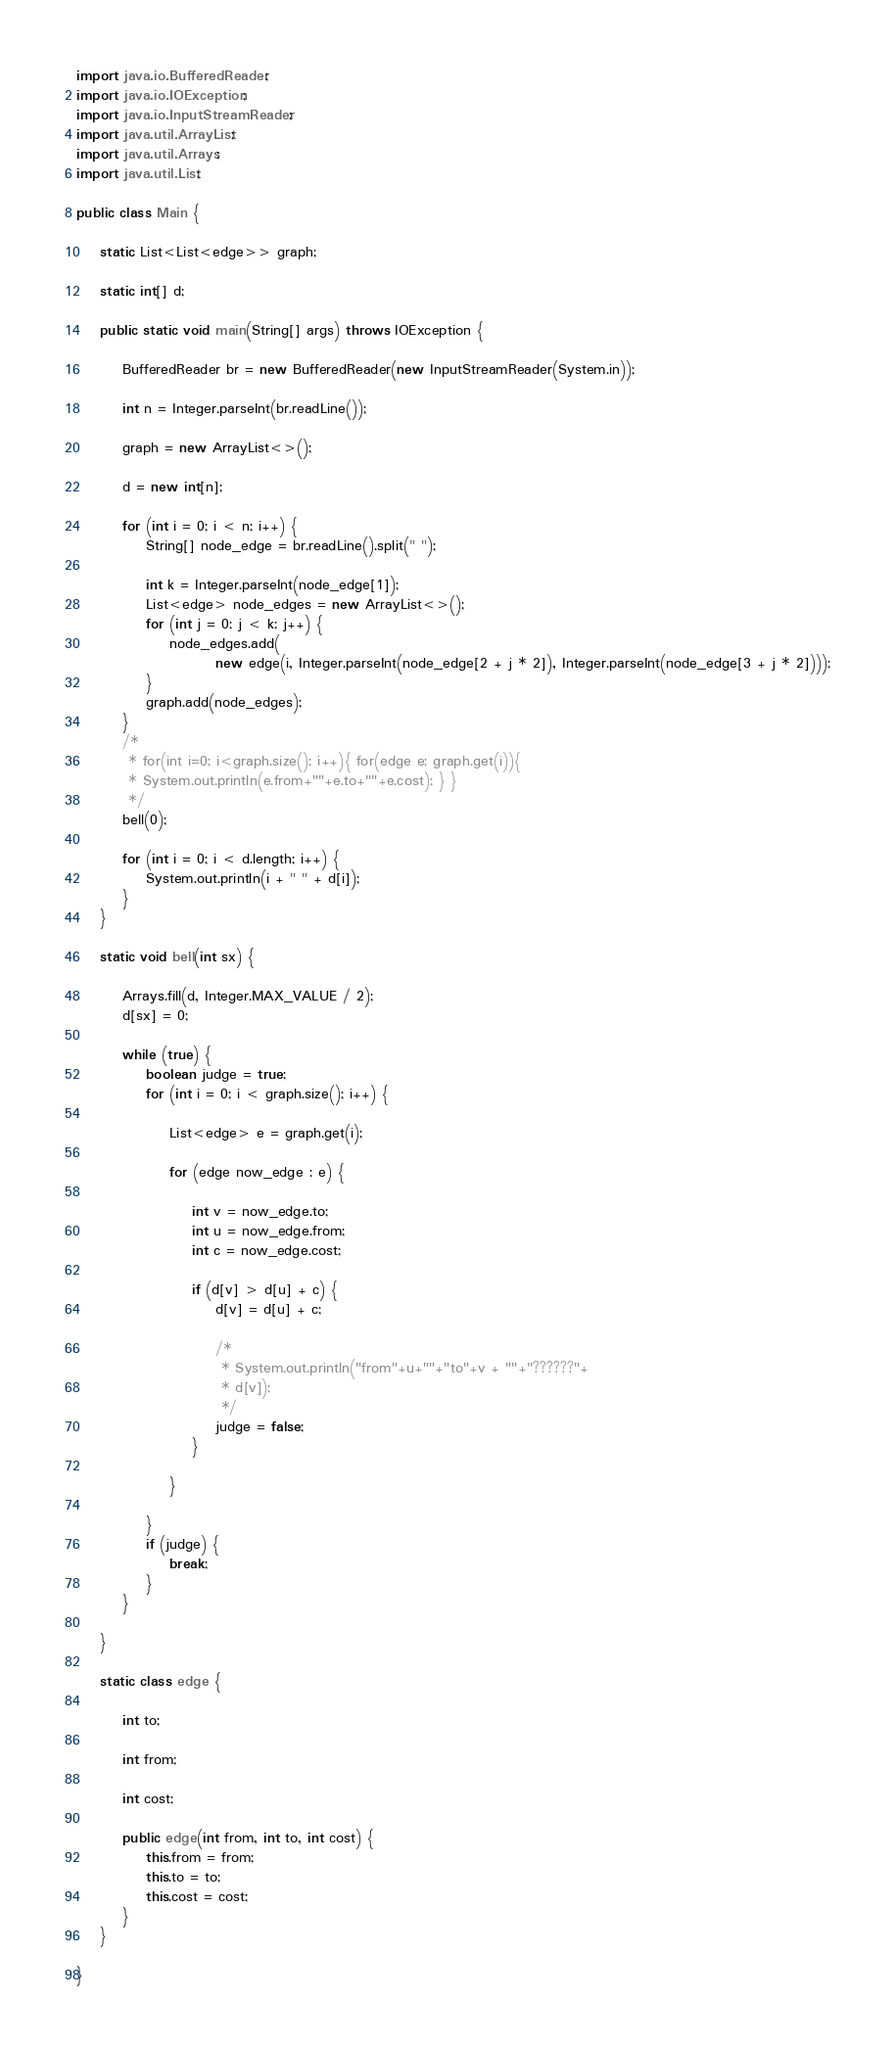Convert code to text. <code><loc_0><loc_0><loc_500><loc_500><_Java_>import java.io.BufferedReader;
import java.io.IOException;
import java.io.InputStreamReader;
import java.util.ArrayList;
import java.util.Arrays;
import java.util.List;

public class Main {

	static List<List<edge>> graph;

	static int[] d;

	public static void main(String[] args) throws IOException {

		BufferedReader br = new BufferedReader(new InputStreamReader(System.in));

		int n = Integer.parseInt(br.readLine());

		graph = new ArrayList<>();

		d = new int[n];

		for (int i = 0; i < n; i++) {
			String[] node_edge = br.readLine().split(" ");

			int k = Integer.parseInt(node_edge[1]);
			List<edge> node_edges = new ArrayList<>();
			for (int j = 0; j < k; j++) {
				node_edges.add(
						new edge(i, Integer.parseInt(node_edge[2 + j * 2]), Integer.parseInt(node_edge[3 + j * 2])));
			}
			graph.add(node_edges);
		}
		/*
		 * for(int i=0; i<graph.size(); i++){ for(edge e: graph.get(i)){
		 * System.out.println(e.from+""+e.to+""+e.cost); } }
		 */
		bell(0);

		for (int i = 0; i < d.length; i++) {
			System.out.println(i + " " + d[i]);
		}
	}

	static void bell(int sx) {

		Arrays.fill(d, Integer.MAX_VALUE / 2);
		d[sx] = 0;

		while (true) {
			boolean judge = true;
			for (int i = 0; i < graph.size(); i++) {

				List<edge> e = graph.get(i);

				for (edge now_edge : e) {

					int v = now_edge.to;
					int u = now_edge.from;
					int c = now_edge.cost;

					if (d[v] > d[u] + c) {
						d[v] = d[u] + c;

						/*
						 * System.out.println("from"+u+""+"to"+v + ""+"??????"+
						 * d[v]);
						 */
						judge = false;
					}

				}

			}
			if (judge) {
				break;
			}
		}

	}

	static class edge {

		int to;

		int from;

		int cost;

		public edge(int from, int to, int cost) {
			this.from = from;
			this.to = to;
			this.cost = cost;
		}
	}

}</code> 